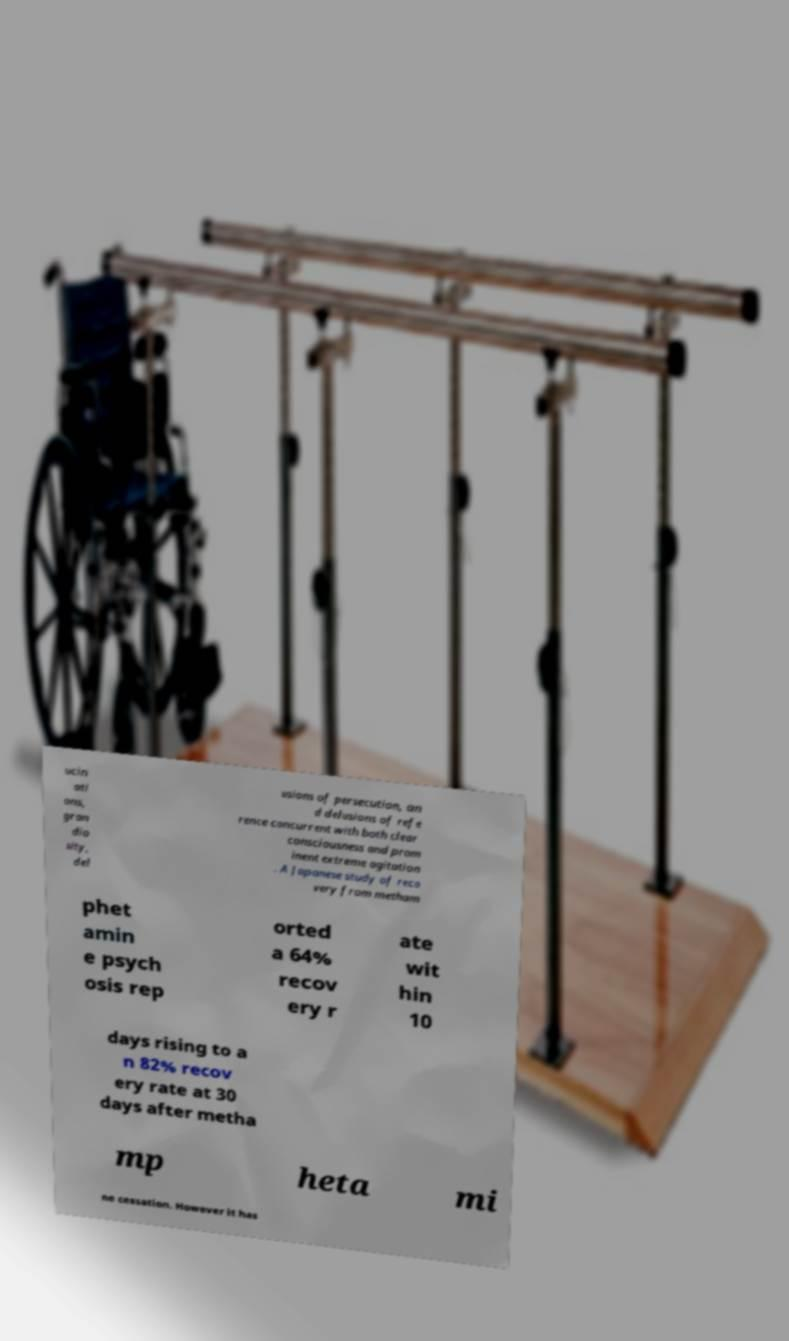There's text embedded in this image that I need extracted. Can you transcribe it verbatim? ucin ati ons, gran dio sity, del usions of persecution, an d delusions of refe rence concurrent with both clear consciousness and prom inent extreme agitation . A Japanese study of reco very from metham phet amin e psych osis rep orted a 64% recov ery r ate wit hin 10 days rising to a n 82% recov ery rate at 30 days after metha mp heta mi ne cessation. However it has 